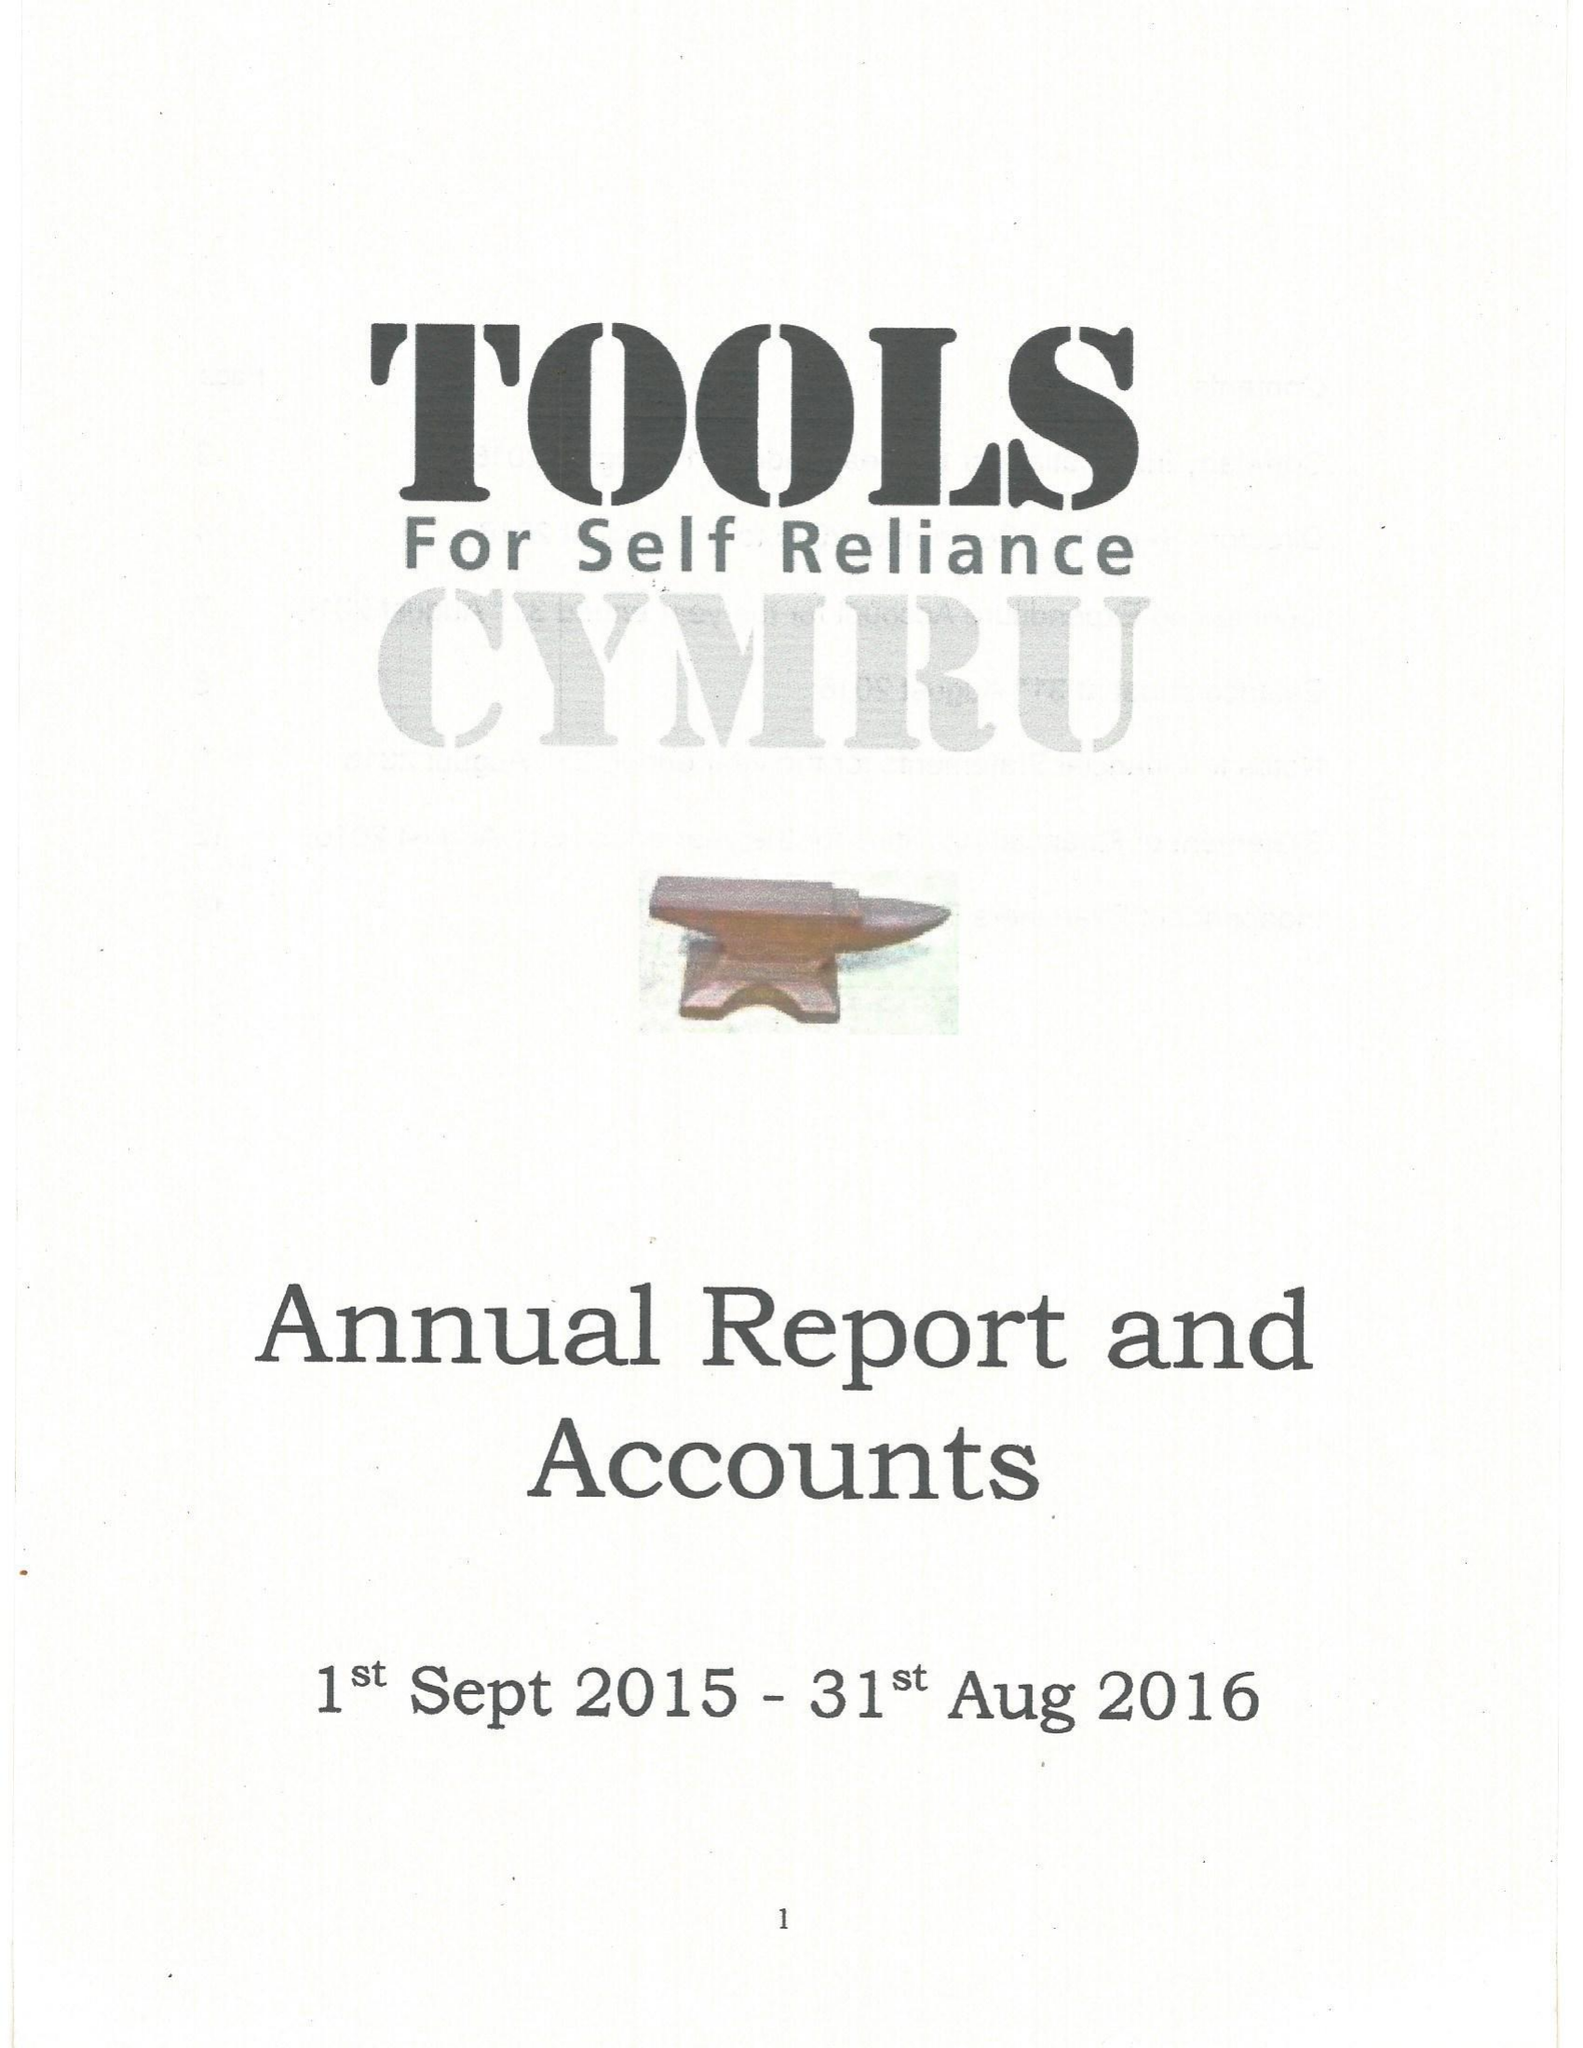What is the value for the income_annually_in_british_pounds?
Answer the question using a single word or phrase. 150891.00 